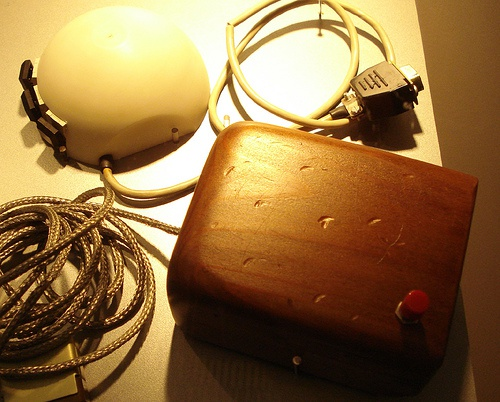Describe the objects in this image and their specific colors. I can see a remote in tan, khaki, orange, and olive tones in this image. 